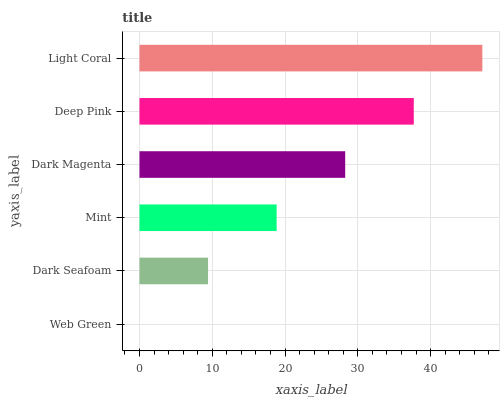Is Web Green the minimum?
Answer yes or no. Yes. Is Light Coral the maximum?
Answer yes or no. Yes. Is Dark Seafoam the minimum?
Answer yes or no. No. Is Dark Seafoam the maximum?
Answer yes or no. No. Is Dark Seafoam greater than Web Green?
Answer yes or no. Yes. Is Web Green less than Dark Seafoam?
Answer yes or no. Yes. Is Web Green greater than Dark Seafoam?
Answer yes or no. No. Is Dark Seafoam less than Web Green?
Answer yes or no. No. Is Dark Magenta the high median?
Answer yes or no. Yes. Is Mint the low median?
Answer yes or no. Yes. Is Deep Pink the high median?
Answer yes or no. No. Is Dark Seafoam the low median?
Answer yes or no. No. 